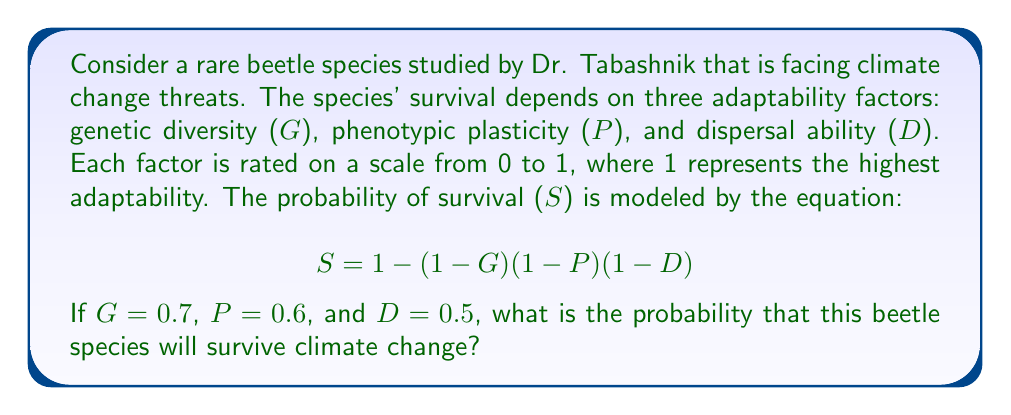Show me your answer to this math problem. To solve this problem, we'll follow these steps:

1) We are given the equation for survival probability:
   $$ S = 1 - (1-G)(1-P)(1-D) $$

2) We are also given the values for each adaptability factor:
   $G = 0.7$ (genetic diversity)
   $P = 0.6$ (phenotypic plasticity)
   $D = 0.5$ (dispersal ability)

3) Let's substitute these values into the equation:
   $$ S = 1 - (1-0.7)(1-0.6)(1-0.5) $$

4) First, let's calculate the values inside the parentheses:
   $1-0.7 = 0.3$
   $1-0.6 = 0.4$
   $1-0.5 = 0.5$

5) Now our equation looks like this:
   $$ S = 1 - (0.3)(0.4)(0.5) $$

6) Multiply the values inside the parentheses:
   $$ S = 1 - 0.06 $$

7) Perform the final subtraction:
   $$ S = 0.94 $$

Therefore, the probability that this beetle species will survive climate change is 0.94 or 94%.
Answer: $0.94$ 